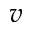<formula> <loc_0><loc_0><loc_500><loc_500>v</formula> 